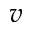<formula> <loc_0><loc_0><loc_500><loc_500>v</formula> 